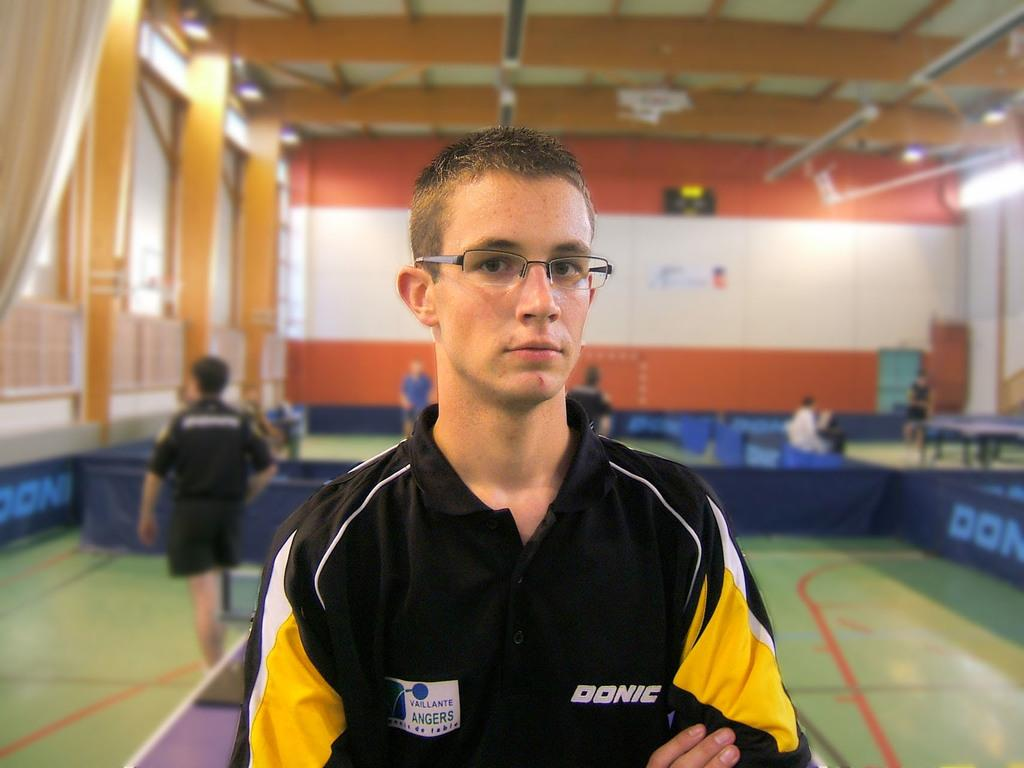What is the main subject of the image? There is a man standing in the image. Can you describe the surroundings of the man? There are people standing in the background of the image. What is located on the right side of the image? There is a table on the right side of the image. What type of lighting is present in the image? There are lights on the ceiling in the image. What type of horn can be seen on the table in the image? There is no horn present on the table in the image. How many eggs are visible on the ceiling lights in the image? There are no eggs visible on the ceiling lights in the image. 